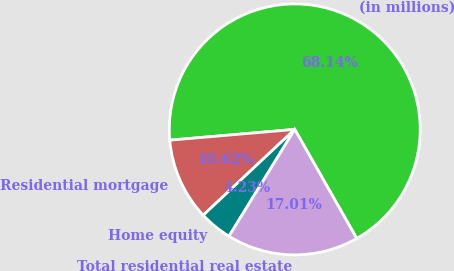Convert chart. <chart><loc_0><loc_0><loc_500><loc_500><pie_chart><fcel>(in millions)<fcel>Residential mortgage<fcel>Home equity<fcel>Total residential real estate<nl><fcel>68.15%<fcel>10.62%<fcel>4.23%<fcel>17.01%<nl></chart> 